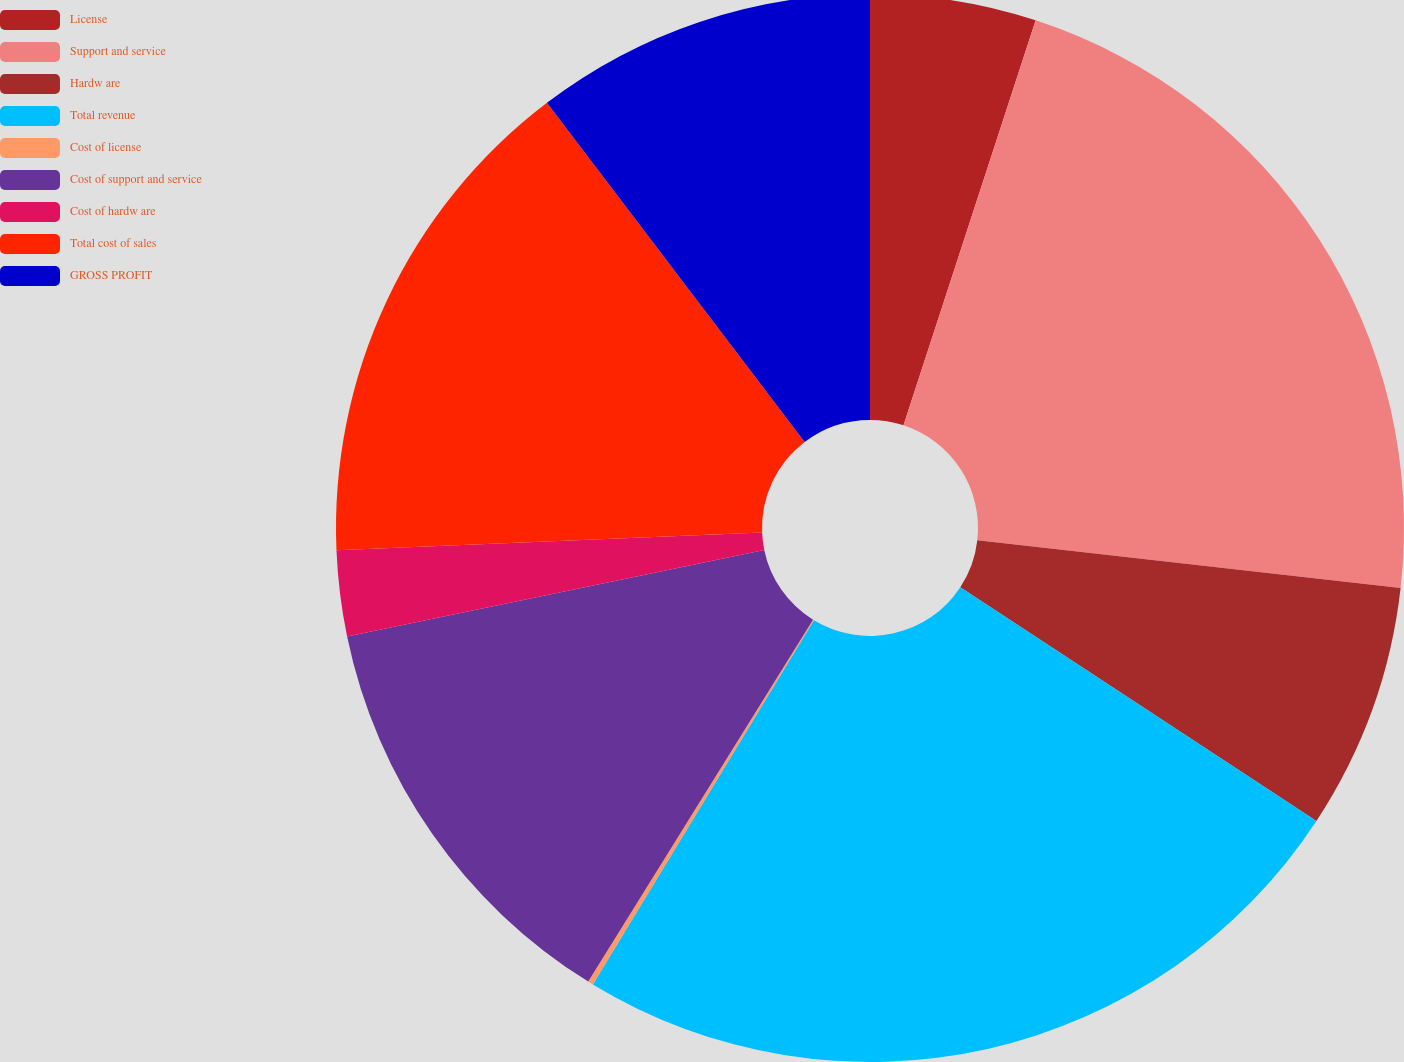Convert chart to OTSL. <chart><loc_0><loc_0><loc_500><loc_500><pie_chart><fcel>License<fcel>Support and service<fcel>Hardw are<fcel>Total revenue<fcel>Cost of license<fcel>Cost of support and service<fcel>Cost of hardw are<fcel>Total cost of sales<fcel>GROSS PROFIT<nl><fcel>5.02%<fcel>21.77%<fcel>7.45%<fcel>24.44%<fcel>0.16%<fcel>12.9%<fcel>2.59%<fcel>15.32%<fcel>10.34%<nl></chart> 